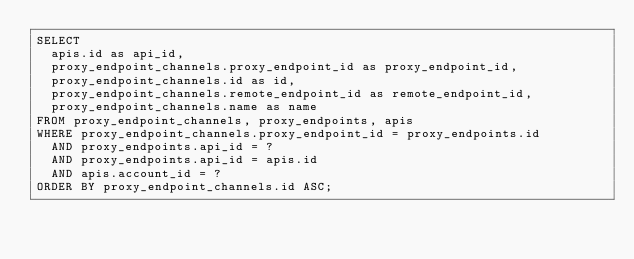<code> <loc_0><loc_0><loc_500><loc_500><_SQL_>SELECT
  apis.id as api_id,
  proxy_endpoint_channels.proxy_endpoint_id as proxy_endpoint_id,
  proxy_endpoint_channels.id as id,
  proxy_endpoint_channels.remote_endpoint_id as remote_endpoint_id,
  proxy_endpoint_channels.name as name
FROM proxy_endpoint_channels, proxy_endpoints, apis
WHERE proxy_endpoint_channels.proxy_endpoint_id = proxy_endpoints.id
  AND proxy_endpoints.api_id = ?
  AND proxy_endpoints.api_id = apis.id
  AND apis.account_id = ?
ORDER BY proxy_endpoint_channels.id ASC;
</code> 